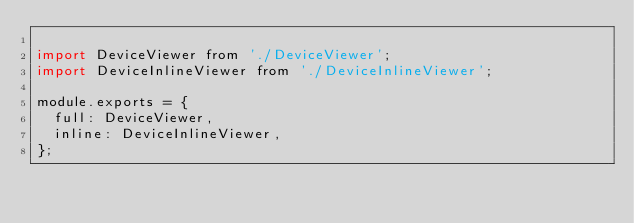Convert code to text. <code><loc_0><loc_0><loc_500><loc_500><_JavaScript_>
import DeviceViewer from './DeviceViewer';
import DeviceInlineViewer from './DeviceInlineViewer';

module.exports = {
  full: DeviceViewer,
  inline: DeviceInlineViewer,
};
</code> 